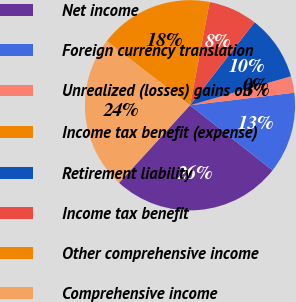Convert chart. <chart><loc_0><loc_0><loc_500><loc_500><pie_chart><fcel>Net income<fcel>Foreign currency translation<fcel>Unrealized (losses) gains on<fcel>Income tax benefit (expense)<fcel>Retirement liability<fcel>Income tax benefit<fcel>Other comprehensive income<fcel>Comprehensive income<nl><fcel>26.16%<fcel>12.54%<fcel>2.52%<fcel>0.02%<fcel>10.03%<fcel>7.53%<fcel>17.55%<fcel>23.65%<nl></chart> 